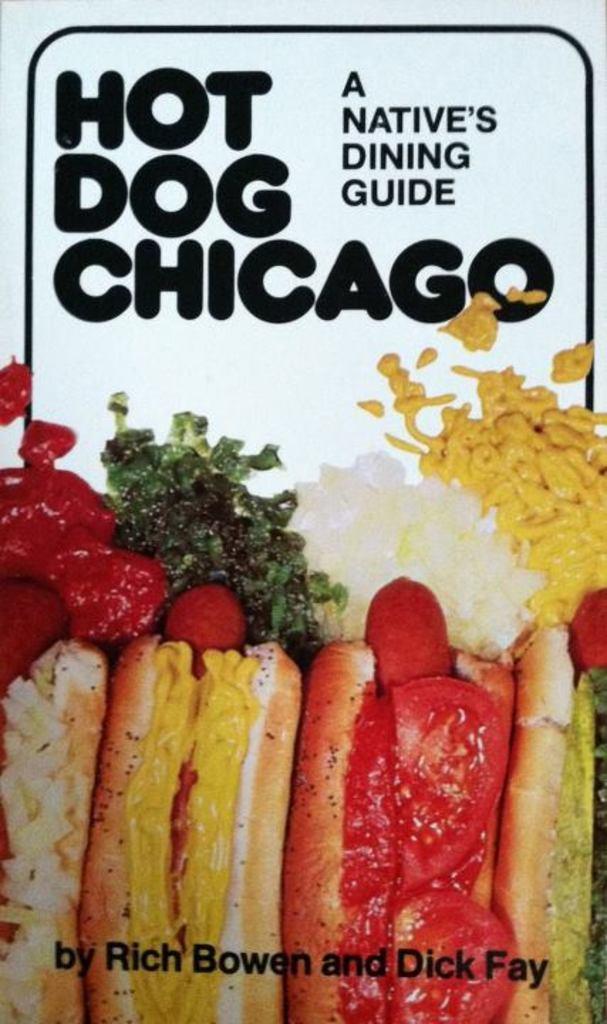Please provide a concise description of this image. In this picture I can see the food at the bottom. At the top there is the text. 